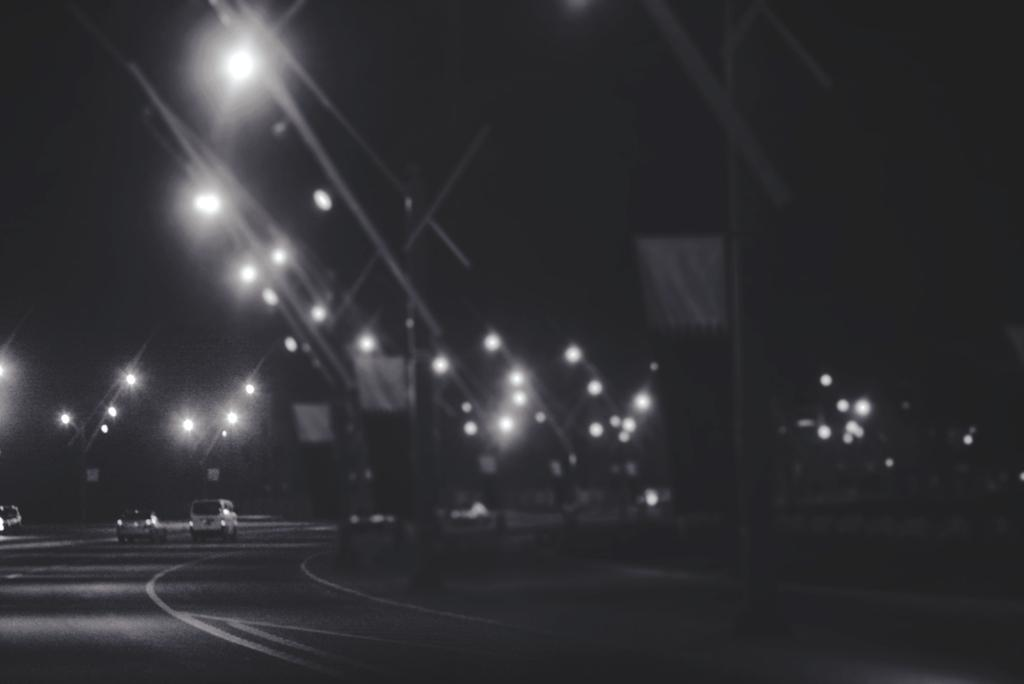What is the main subject of the image? The main subject of the image is vehicles on the road. Where are the vehicles located in the image? The vehicles are in the center of the image. What can be seen in the background of the image? There are poles with boards and lights in the background of the image. Can you see any fish swimming near the seashore in the image? There is no seashore or fish present in the image; it features vehicles on the road with poles and lights in the background. 